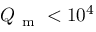Convert formula to latex. <formula><loc_0><loc_0><loc_500><loc_500>Q _ { m } < 1 0 ^ { 4 }</formula> 